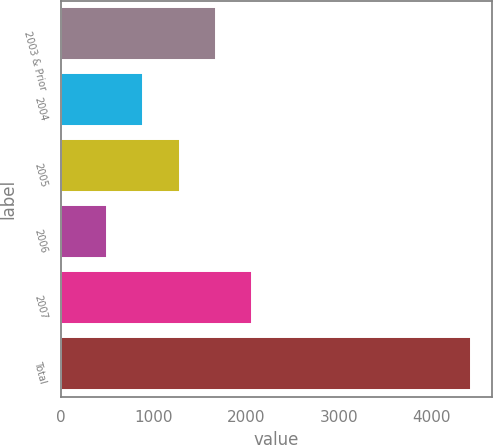Convert chart. <chart><loc_0><loc_0><loc_500><loc_500><bar_chart><fcel>2003 & Prior<fcel>2004<fcel>2005<fcel>2006<fcel>2007<fcel>Total<nl><fcel>1672.42<fcel>884.54<fcel>1278.48<fcel>490.6<fcel>2066.36<fcel>4430<nl></chart> 